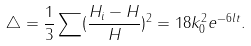Convert formula to latex. <formula><loc_0><loc_0><loc_500><loc_500>\triangle = \frac { 1 } { 3 } \sum ( \frac { H _ { i } - H } { H } ) ^ { 2 } = 1 8 k _ { 0 } ^ { 2 } e ^ { - 6 l t } .</formula> 